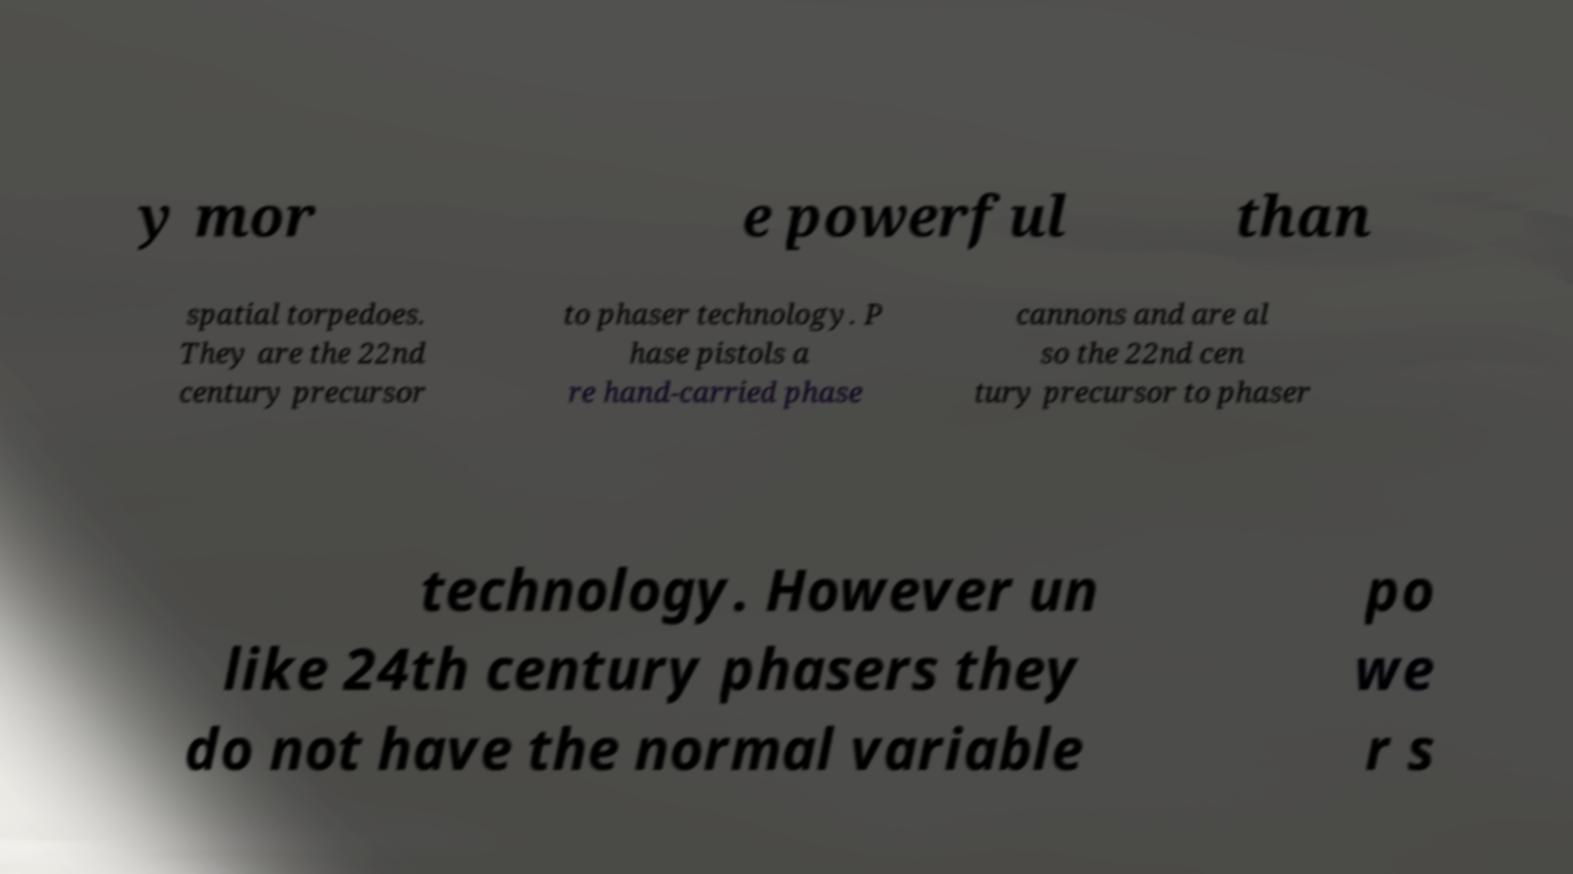Could you assist in decoding the text presented in this image and type it out clearly? y mor e powerful than spatial torpedoes. They are the 22nd century precursor to phaser technology. P hase pistols a re hand-carried phase cannons and are al so the 22nd cen tury precursor to phaser technology. However un like 24th century phasers they do not have the normal variable po we r s 